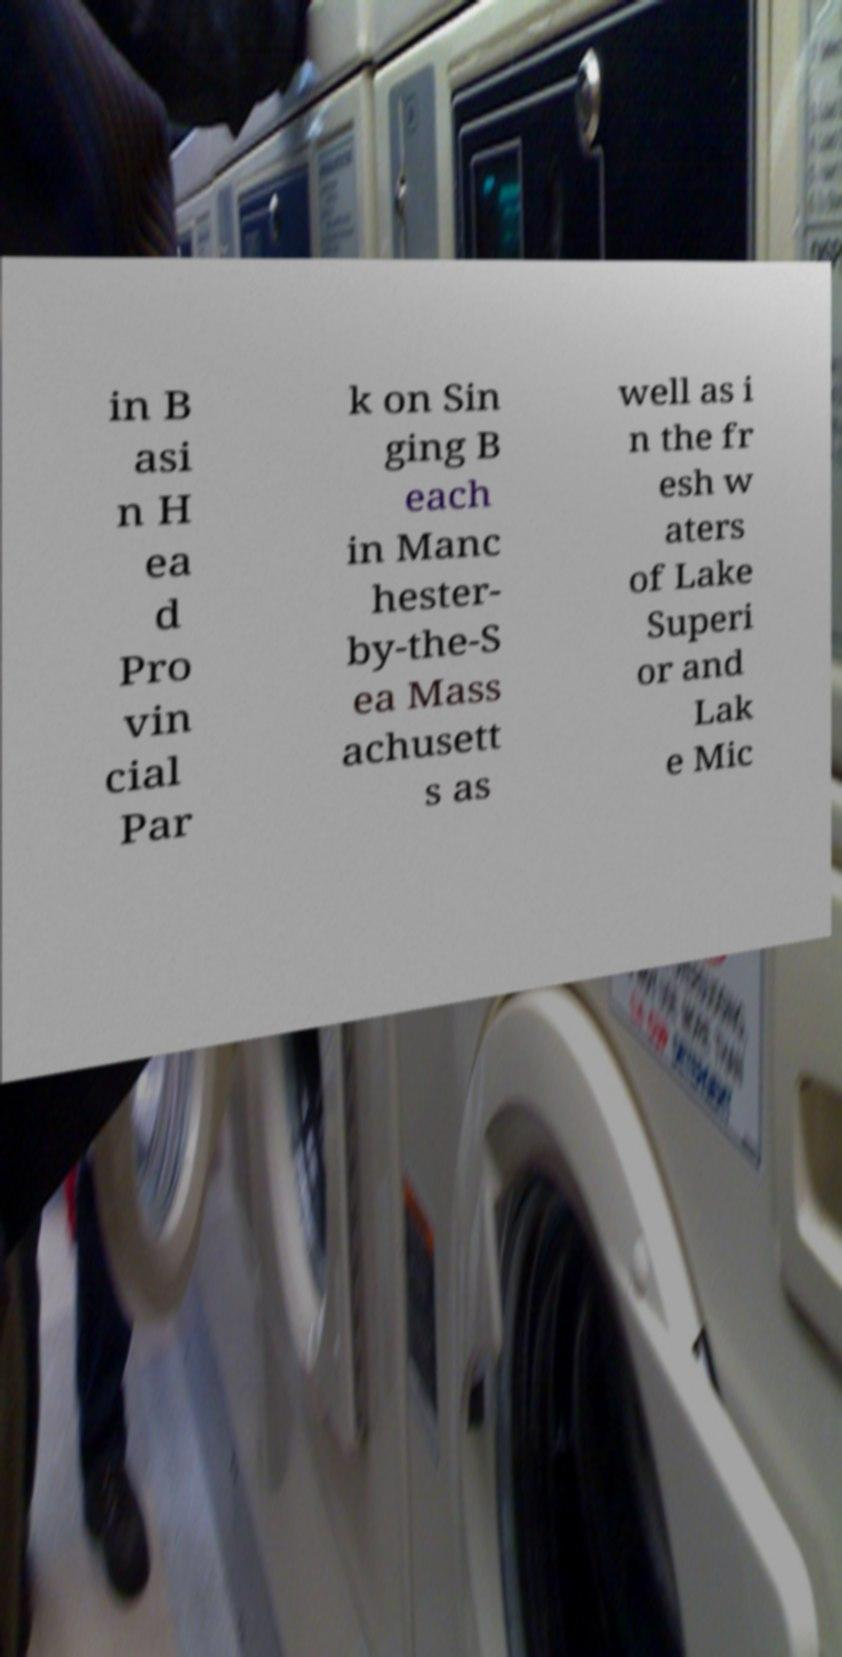For documentation purposes, I need the text within this image transcribed. Could you provide that? in B asi n H ea d Pro vin cial Par k on Sin ging B each in Manc hester- by-the-S ea Mass achusett s as well as i n the fr esh w aters of Lake Superi or and Lak e Mic 